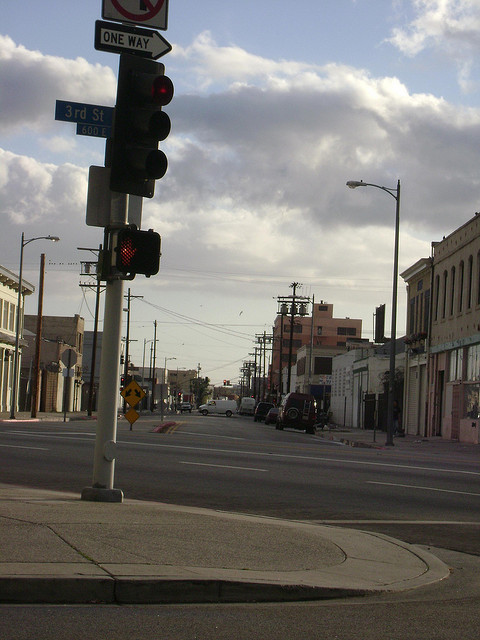Please transcribe the text in this image. ONE WAY 3rd SI 588 